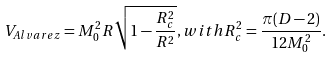Convert formula to latex. <formula><loc_0><loc_0><loc_500><loc_500>V _ { A l v a r e z } = M _ { 0 } ^ { 2 } R \sqrt { 1 - \frac { R _ { c } ^ { 2 } } { R ^ { 2 } } } , w i t h R _ { c } ^ { 2 } = \frac { \pi ( D - 2 ) } { 1 2 M _ { 0 } ^ { 2 } } .</formula> 